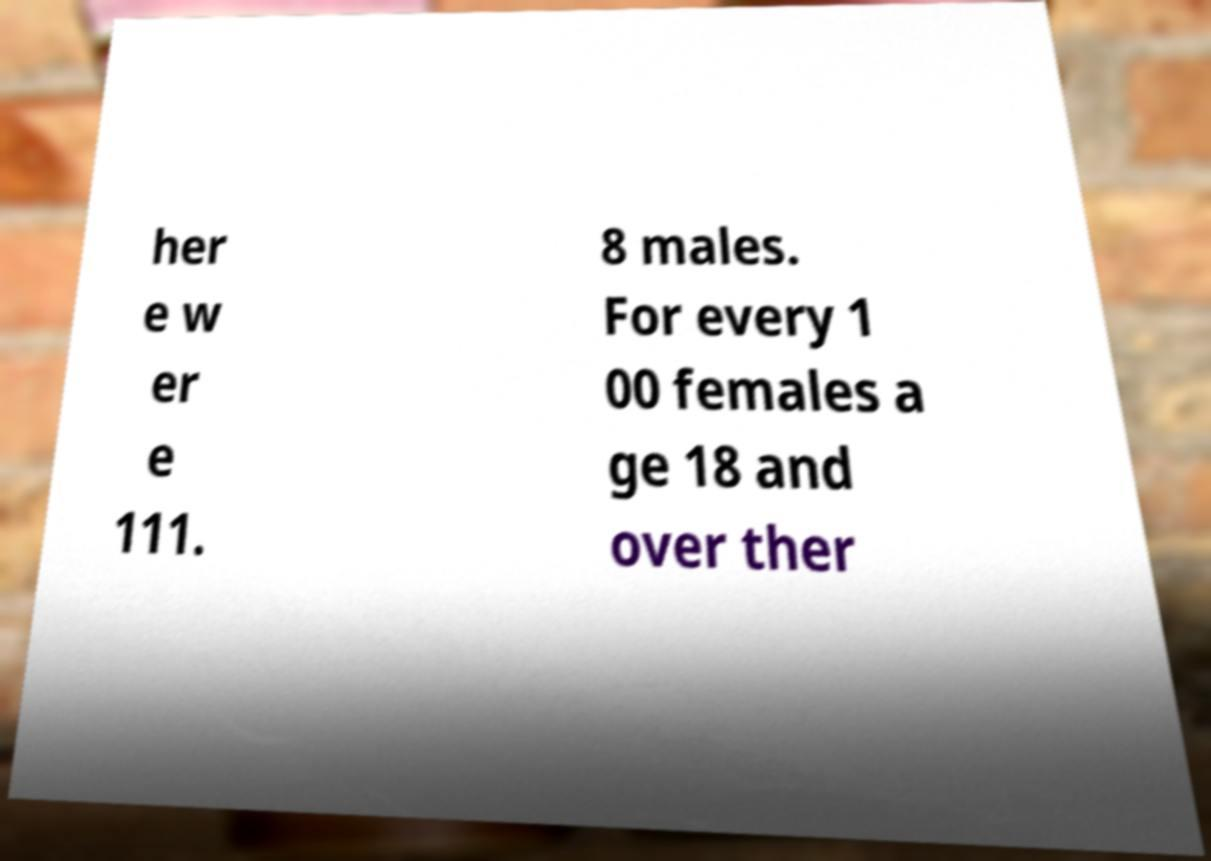I need the written content from this picture converted into text. Can you do that? her e w er e 111. 8 males. For every 1 00 females a ge 18 and over ther 